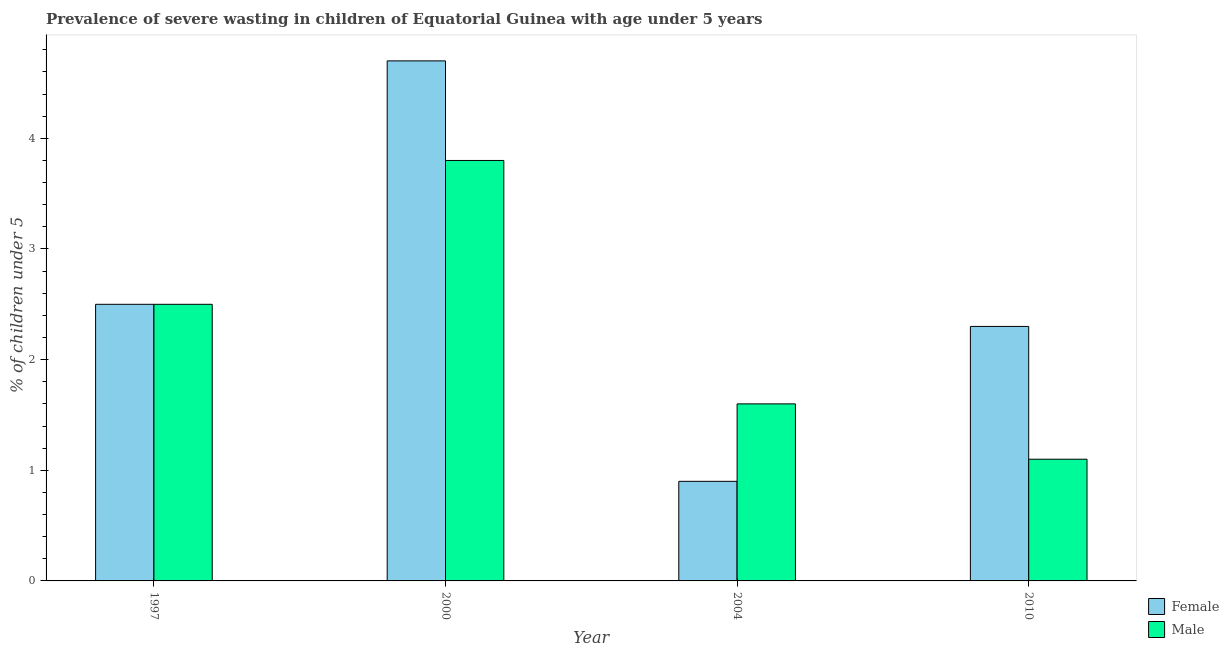Are the number of bars on each tick of the X-axis equal?
Make the answer very short. Yes. How many bars are there on the 3rd tick from the left?
Give a very brief answer. 2. How many bars are there on the 3rd tick from the right?
Ensure brevity in your answer.  2. What is the label of the 2nd group of bars from the left?
Make the answer very short. 2000. What is the percentage of undernourished female children in 2000?
Provide a short and direct response. 4.7. Across all years, what is the maximum percentage of undernourished male children?
Make the answer very short. 3.8. Across all years, what is the minimum percentage of undernourished female children?
Ensure brevity in your answer.  0.9. In which year was the percentage of undernourished female children maximum?
Provide a short and direct response. 2000. In which year was the percentage of undernourished female children minimum?
Offer a very short reply. 2004. What is the total percentage of undernourished male children in the graph?
Your answer should be very brief. 9. What is the difference between the percentage of undernourished female children in 2004 and that in 2010?
Your response must be concise. -1.4. What is the difference between the percentage of undernourished female children in 2010 and the percentage of undernourished male children in 2000?
Your answer should be compact. -2.4. What is the average percentage of undernourished female children per year?
Give a very brief answer. 2.6. What is the ratio of the percentage of undernourished female children in 2000 to that in 2010?
Make the answer very short. 2.04. Is the difference between the percentage of undernourished male children in 2000 and 2004 greater than the difference between the percentage of undernourished female children in 2000 and 2004?
Make the answer very short. No. What is the difference between the highest and the second highest percentage of undernourished female children?
Give a very brief answer. 2.2. What is the difference between the highest and the lowest percentage of undernourished female children?
Give a very brief answer. 3.8. In how many years, is the percentage of undernourished female children greater than the average percentage of undernourished female children taken over all years?
Provide a short and direct response. 1. How many bars are there?
Make the answer very short. 8. Are all the bars in the graph horizontal?
Offer a terse response. No. Are the values on the major ticks of Y-axis written in scientific E-notation?
Ensure brevity in your answer.  No. Does the graph contain any zero values?
Provide a succinct answer. No. Does the graph contain grids?
Ensure brevity in your answer.  No. How many legend labels are there?
Provide a short and direct response. 2. How are the legend labels stacked?
Provide a succinct answer. Vertical. What is the title of the graph?
Offer a terse response. Prevalence of severe wasting in children of Equatorial Guinea with age under 5 years. What is the label or title of the Y-axis?
Give a very brief answer.  % of children under 5. What is the  % of children under 5 in Female in 2000?
Offer a terse response. 4.7. What is the  % of children under 5 in Male in 2000?
Offer a very short reply. 3.8. What is the  % of children under 5 of Female in 2004?
Ensure brevity in your answer.  0.9. What is the  % of children under 5 in Male in 2004?
Make the answer very short. 1.6. What is the  % of children under 5 in Female in 2010?
Your answer should be compact. 2.3. What is the  % of children under 5 of Male in 2010?
Your response must be concise. 1.1. Across all years, what is the maximum  % of children under 5 in Female?
Offer a terse response. 4.7. Across all years, what is the maximum  % of children under 5 in Male?
Keep it short and to the point. 3.8. Across all years, what is the minimum  % of children under 5 of Female?
Provide a short and direct response. 0.9. Across all years, what is the minimum  % of children under 5 in Male?
Your answer should be very brief. 1.1. What is the total  % of children under 5 in Female in the graph?
Give a very brief answer. 10.4. What is the total  % of children under 5 in Male in the graph?
Provide a succinct answer. 9. What is the difference between the  % of children under 5 of Female in 2000 and that in 2004?
Offer a terse response. 3.8. What is the difference between the  % of children under 5 of Female in 2000 and that in 2010?
Offer a terse response. 2.4. What is the difference between the  % of children under 5 in Female in 2004 and that in 2010?
Make the answer very short. -1.4. What is the difference between the  % of children under 5 of Male in 2004 and that in 2010?
Keep it short and to the point. 0.5. What is the difference between the  % of children under 5 in Female in 1997 and the  % of children under 5 in Male in 2000?
Provide a succinct answer. -1.3. What is the difference between the  % of children under 5 of Female in 1997 and the  % of children under 5 of Male in 2010?
Provide a succinct answer. 1.4. What is the difference between the  % of children under 5 of Female in 2000 and the  % of children under 5 of Male in 2004?
Ensure brevity in your answer.  3.1. What is the difference between the  % of children under 5 in Female in 2000 and the  % of children under 5 in Male in 2010?
Your response must be concise. 3.6. What is the difference between the  % of children under 5 in Female in 2004 and the  % of children under 5 in Male in 2010?
Your response must be concise. -0.2. What is the average  % of children under 5 in Female per year?
Provide a succinct answer. 2.6. What is the average  % of children under 5 in Male per year?
Your response must be concise. 2.25. In the year 1997, what is the difference between the  % of children under 5 of Female and  % of children under 5 of Male?
Your answer should be very brief. 0. In the year 2010, what is the difference between the  % of children under 5 of Female and  % of children under 5 of Male?
Make the answer very short. 1.2. What is the ratio of the  % of children under 5 in Female in 1997 to that in 2000?
Make the answer very short. 0.53. What is the ratio of the  % of children under 5 in Male in 1997 to that in 2000?
Provide a succinct answer. 0.66. What is the ratio of the  % of children under 5 in Female in 1997 to that in 2004?
Keep it short and to the point. 2.78. What is the ratio of the  % of children under 5 of Male in 1997 to that in 2004?
Offer a very short reply. 1.56. What is the ratio of the  % of children under 5 of Female in 1997 to that in 2010?
Offer a terse response. 1.09. What is the ratio of the  % of children under 5 of Male in 1997 to that in 2010?
Make the answer very short. 2.27. What is the ratio of the  % of children under 5 in Female in 2000 to that in 2004?
Offer a terse response. 5.22. What is the ratio of the  % of children under 5 in Male in 2000 to that in 2004?
Make the answer very short. 2.38. What is the ratio of the  % of children under 5 of Female in 2000 to that in 2010?
Provide a succinct answer. 2.04. What is the ratio of the  % of children under 5 in Male in 2000 to that in 2010?
Your response must be concise. 3.45. What is the ratio of the  % of children under 5 in Female in 2004 to that in 2010?
Your answer should be compact. 0.39. What is the ratio of the  % of children under 5 of Male in 2004 to that in 2010?
Keep it short and to the point. 1.45. 